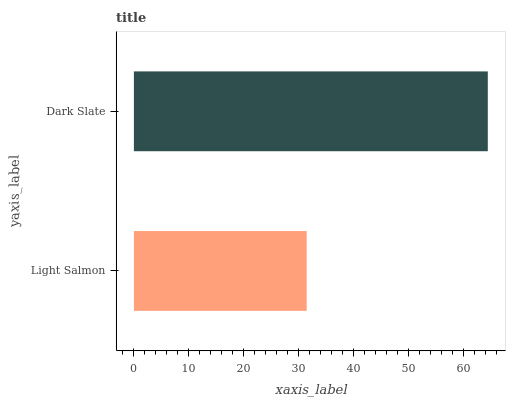Is Light Salmon the minimum?
Answer yes or no. Yes. Is Dark Slate the maximum?
Answer yes or no. Yes. Is Dark Slate the minimum?
Answer yes or no. No. Is Dark Slate greater than Light Salmon?
Answer yes or no. Yes. Is Light Salmon less than Dark Slate?
Answer yes or no. Yes. Is Light Salmon greater than Dark Slate?
Answer yes or no. No. Is Dark Slate less than Light Salmon?
Answer yes or no. No. Is Dark Slate the high median?
Answer yes or no. Yes. Is Light Salmon the low median?
Answer yes or no. Yes. Is Light Salmon the high median?
Answer yes or no. No. Is Dark Slate the low median?
Answer yes or no. No. 